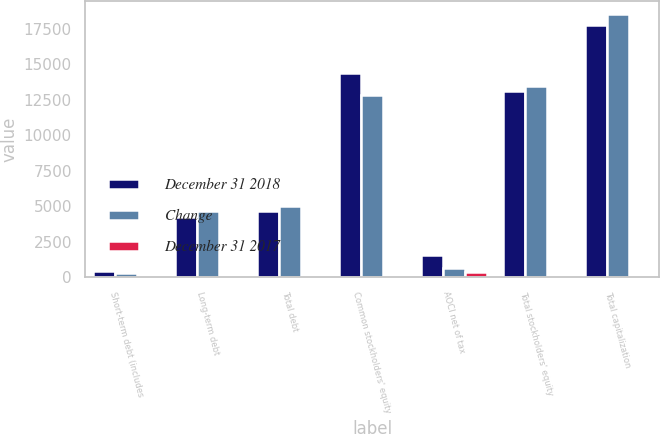Convert chart to OTSL. <chart><loc_0><loc_0><loc_500><loc_500><stacked_bar_chart><ecel><fcel>Short-term debt (includes<fcel>Long-term debt<fcel>Total debt<fcel>Common stockholders' equity<fcel>AOCI net of tax<fcel>Total stockholders' equity<fcel>Total capitalization<nl><fcel>December 31 2018<fcel>413<fcel>4265<fcel>4678<fcel>14346<fcel>1579<fcel>13101<fcel>17779<nl><fcel>Change<fcel>320<fcel>4678<fcel>4998<fcel>12831<fcel>663<fcel>13494<fcel>18492<nl><fcel>December 31 2017<fcel>29<fcel>9<fcel>6<fcel>12<fcel>338<fcel>3<fcel>4<nl></chart> 